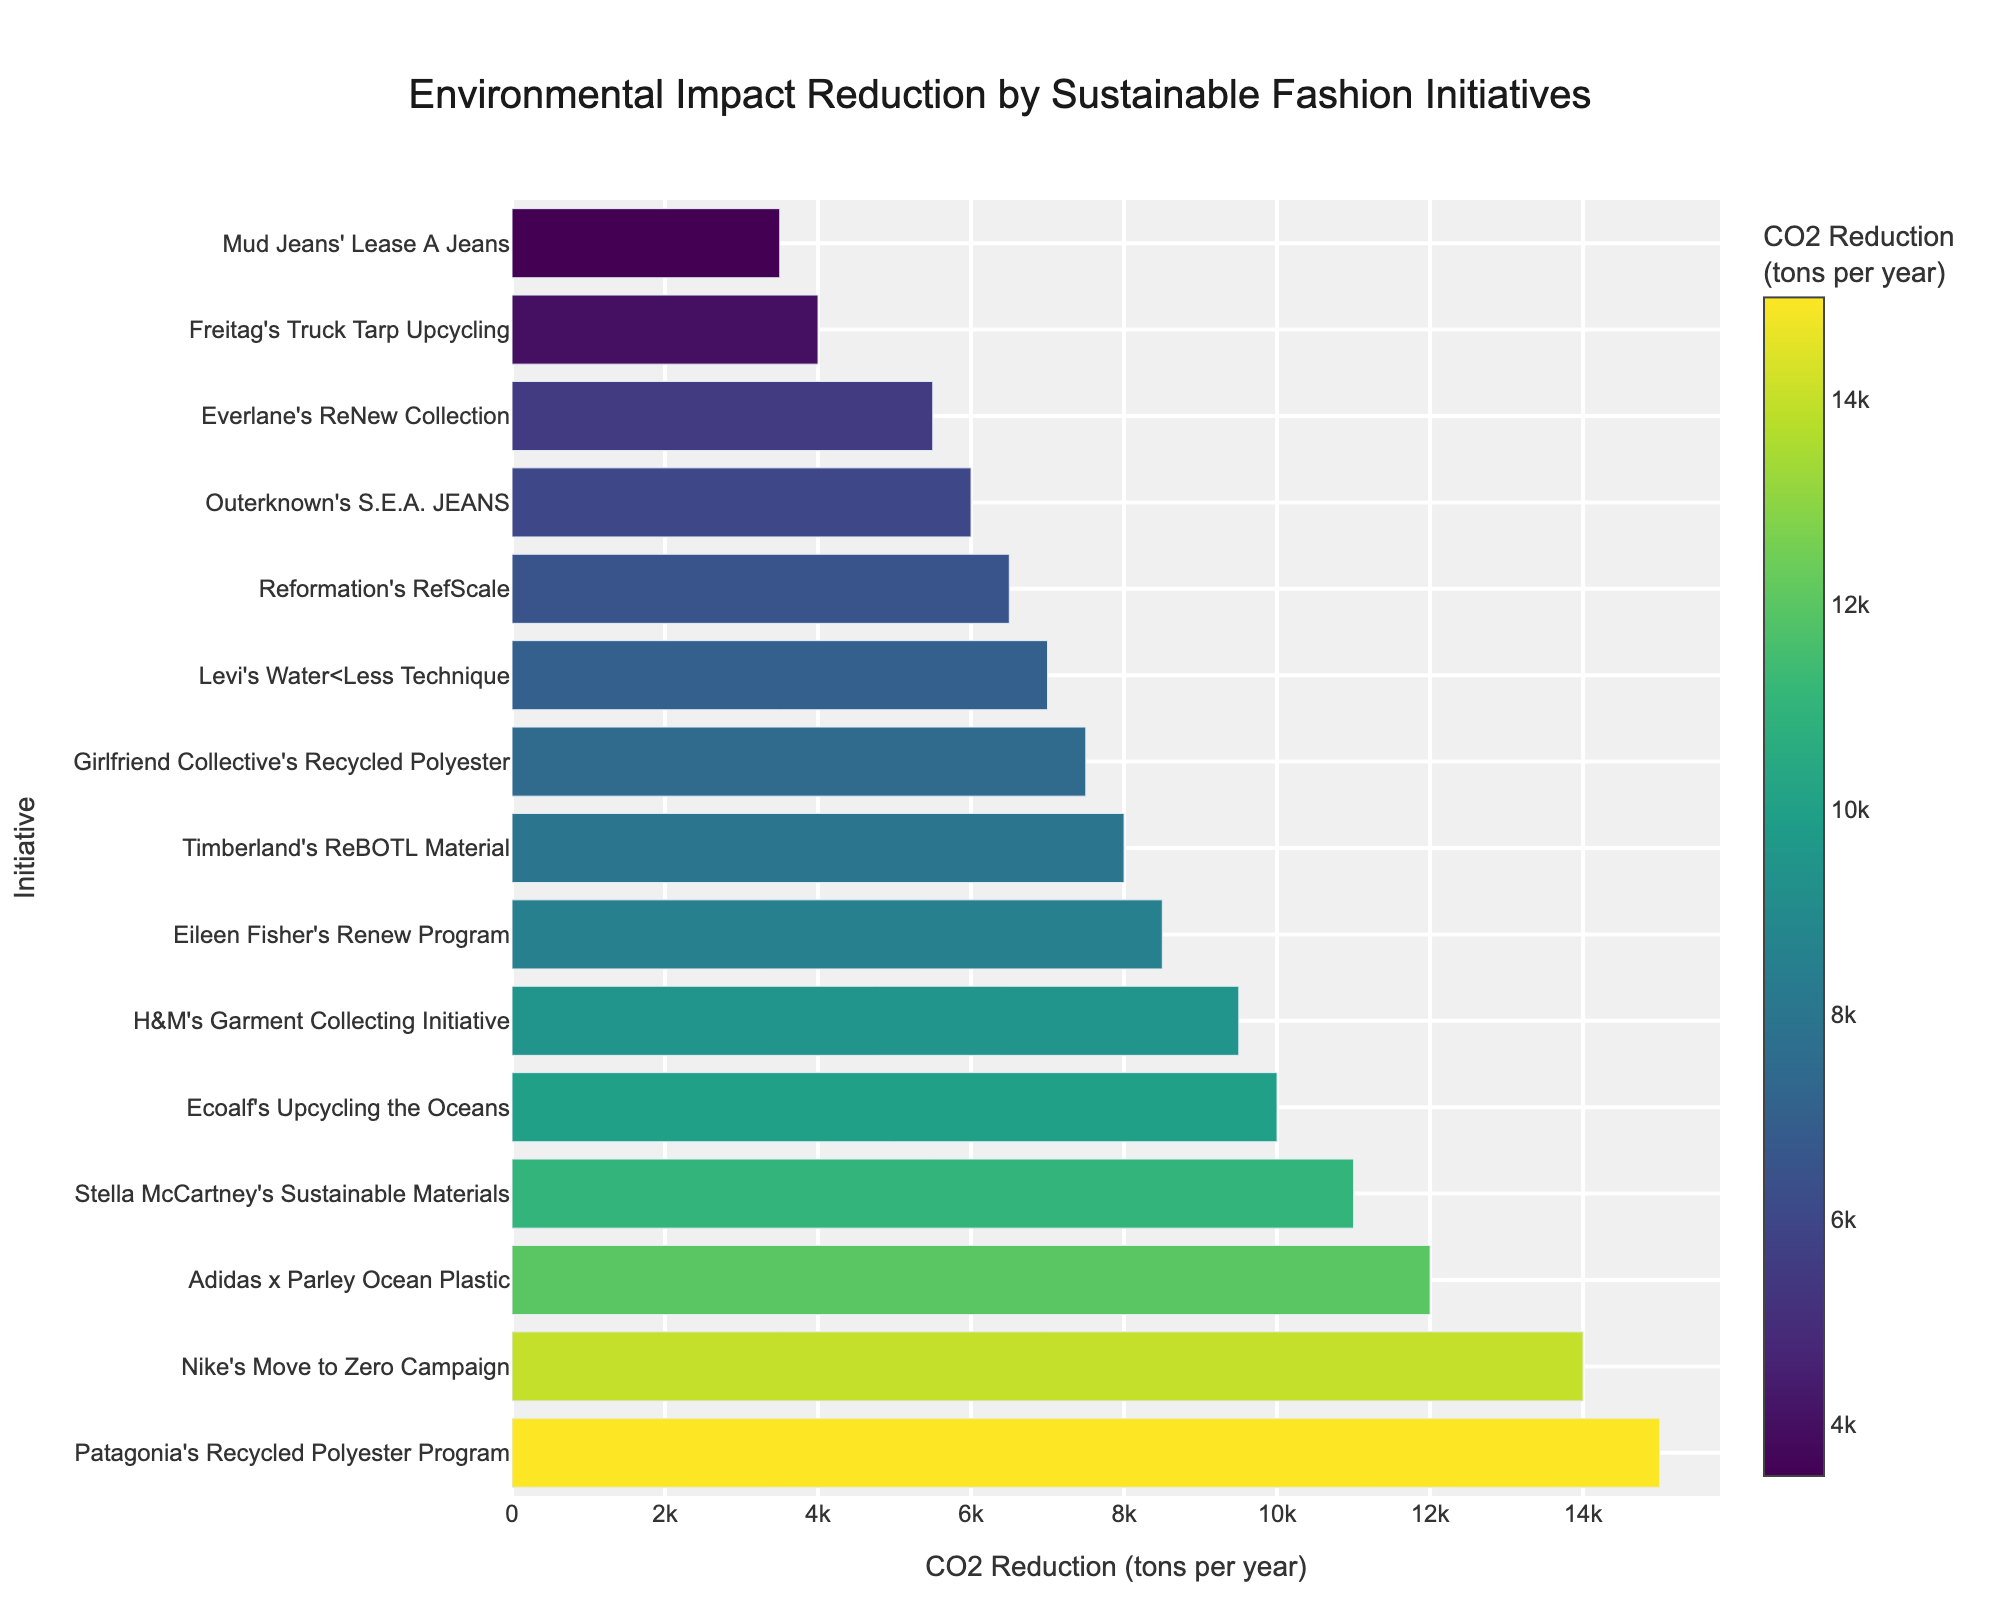Which initiative has the highest CO2 reduction? Look at the initiative with the longest bar. Patagonia's Recycled Polyester Program has the longest bar with a CO2 reduction of 15,000 tons per year.
Answer: Patagonia's Recycled Polyester Program Between Nike's Move to Zero Campaign and Adidas x Parley Ocean Plastic, which one reduces more CO2 emissions? Compare the lengths of the two bars. Nike's Move to Zero Campaign reduces 14,000 tons per year, while Adidas x Parley Ocean Plastic reduces 12,000 tons per year.
Answer: Nike's Move to Zero Campaign What is the total CO2 reduction from Levi's Water<Less Technique and Reformation's RefScale? Add the CO2 reductions from both initiatives: 7,000 + 6,500 = 13,500 tons per year.
Answer: 13,500 tons per year How does Ecoalf's CO2 reduction compare to Timberland's ReBOTL Material? Compare both bars. Ecoalf reduces 10,000 tons per year while Timberland reduces 8,000 tons per year, so Ecoalf reduces more.
Answer: Ecoalf Which initiatives reduce CO2 emissions by more than 10,000 tons per year? Look for bars exceeding the 10,000 mark. They are Patagonia's Recycled Polyester Program, Nike's Move to Zero Campaign, Adidas x Parley Ocean Plastic, and Stella McCartney's Sustainable Materials.
Answer: Patagonia's Recycled Polyester Program, Nike's Move to Zero Campaign, Adidas x Parley Ocean Plastic, Stella McCartney's Sustainable Materials What is the average CO2 reduction of the top three initiatives? Add the CO2 reductions of the top three initiatives and divide by 3: (15,000 + 14,000 + 12,000) / 3 = 41,000 / 3 ≈ 13,667 tons per year.
Answer: 13,667 tons per year Which program by Eileen Fisher reduces CO2? Look for Eileen Fisher's initiative. Eileen Fisher's Renew Program reduces 8,500 tons per year.
Answer: Eileen Fisher's Renew Program What is the combined CO2 reduction of Reformation's RefScale, Everlane's ReNew Collection, and Mud Jeans' Lease A Jeans? Add the reductions of the three initiatives: 6,500 + 5,500 + 3,500 = 15,500 tons per year.
Answer: 15,500 tons per year 